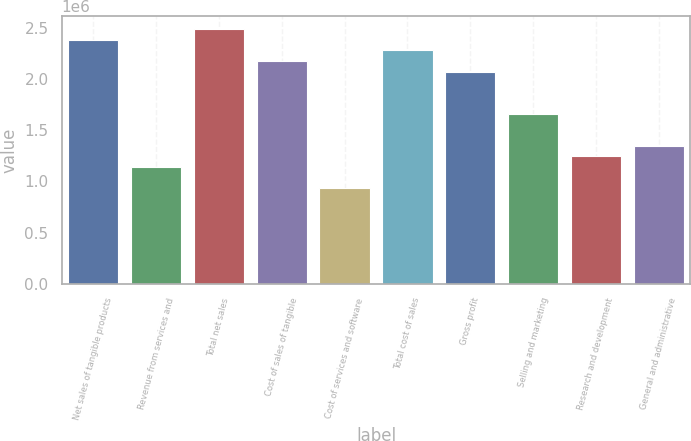Convert chart. <chart><loc_0><loc_0><loc_500><loc_500><bar_chart><fcel>Net sales of tangible products<fcel>Revenue from services and<fcel>Total net sales<fcel>Cost of sales of tangible<fcel>Cost of services and software<fcel>Total cost of sales<fcel>Gross profit<fcel>Selling and marketing<fcel>Research and development<fcel>General and administrative<nl><fcel>2.38776e+06<fcel>1.14197e+06<fcel>2.49157e+06<fcel>2.18013e+06<fcel>934344<fcel>2.28394e+06<fcel>2.07631e+06<fcel>1.66105e+06<fcel>1.24579e+06<fcel>1.34961e+06<nl></chart> 